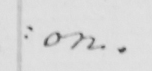What does this handwritten line say? : ion . 